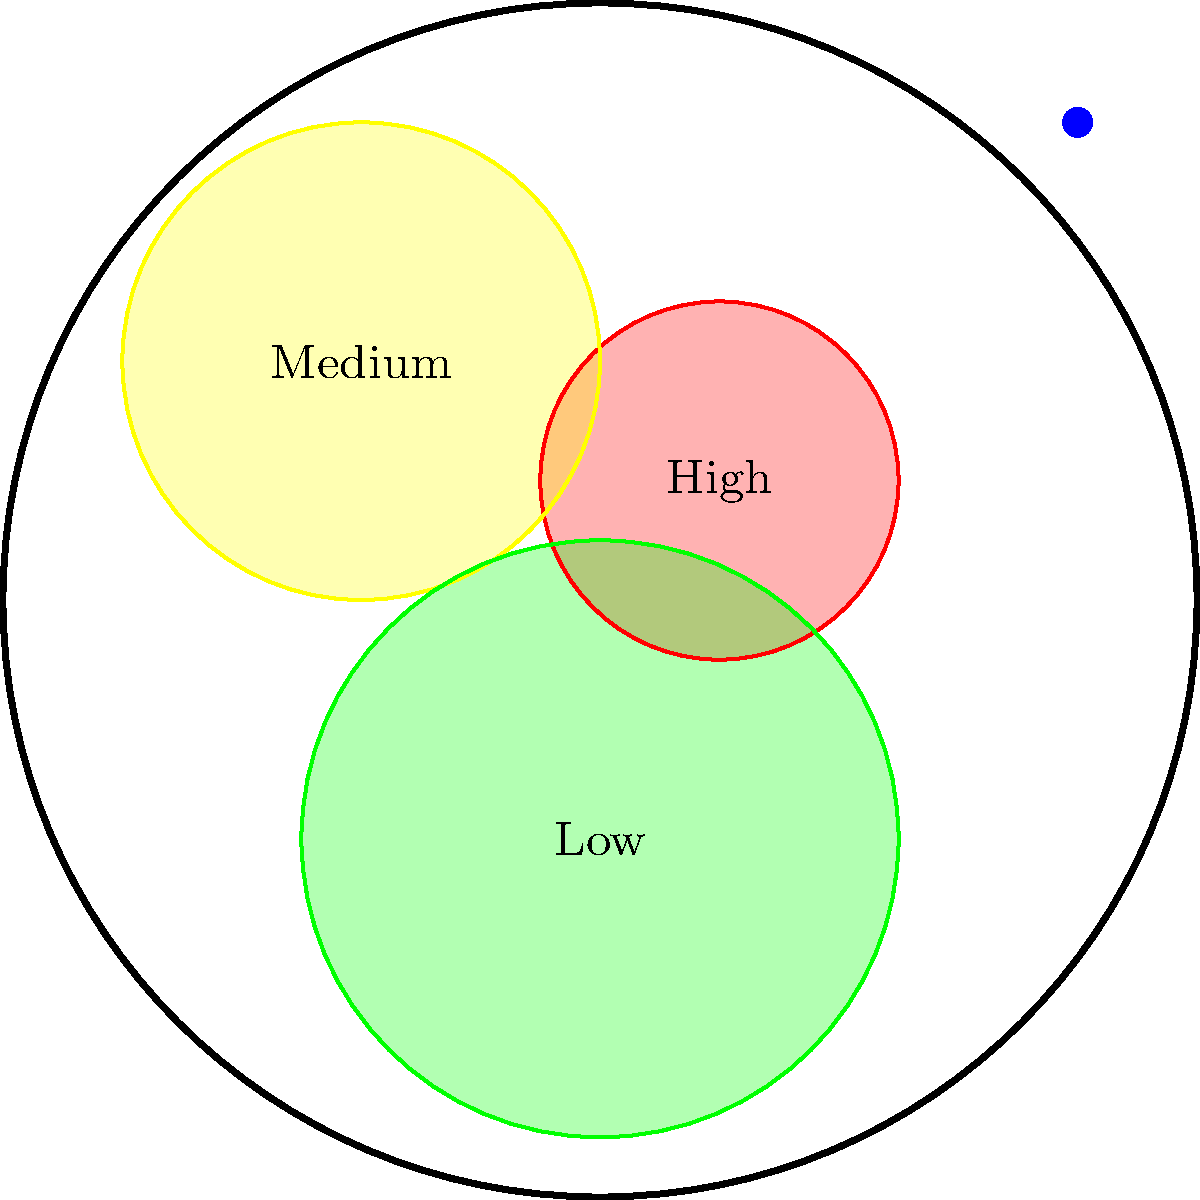Given the population density map of a small town, where should the main water distribution pipeline be placed to ensure efficient and equitable water supply while minimizing costs? Justify your answer considering the principles of integrity and fairness in public service. To design an efficient and equitable water distribution system, we need to consider several factors:

1. Population density: The main pipeline should prioritize areas with higher population density to serve the maximum number of people efficiently.

2. Distance from water source: Shorter distances reduce infrastructure costs and pressure losses.

3. Fairness and equity: All areas should have access to clean water, regardless of population density.

4. Cost-effectiveness: The system should minimize overall costs while maintaining service quality.

5. Future expansion: The design should allow for potential growth and development.

Considering these factors, the optimal placement of the main water distribution pipeline would be:

a) Start from the water source at the top right of the map.

b) Run the main pipeline towards the high-density area (red) first, as it will serve the most people per unit length of pipe.

c) Continue the pipeline towards the medium-density area (yellow) to ensure fair distribution.

d) Extend a branch towards the low-density area (green) to provide equitable access.

e) Create a loop system by connecting back to the water source, improving water pressure and providing redundancy in case of pipe failures.

This layout ensures:
1. Efficient service to high-density areas
2. Fair access for all population densities
3. Cost-effective design by prioritizing areas with more users
4. Flexibility for future expansion

By following this approach, we maintain integrity in public service by providing equitable access to clean water while efficiently using public resources.
Answer: Main pipeline: Water source → High-density → Medium-density → Low-density → Loop back to source 